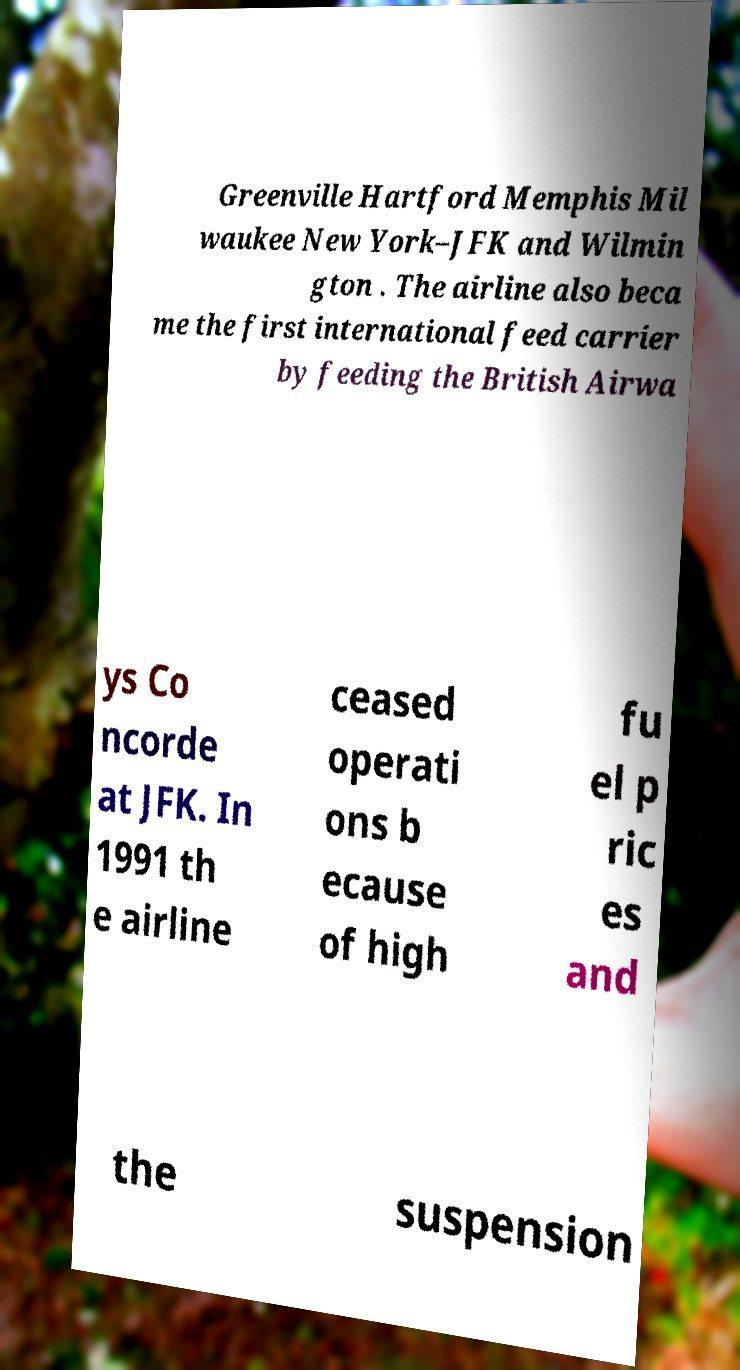Can you read and provide the text displayed in the image?This photo seems to have some interesting text. Can you extract and type it out for me? Greenville Hartford Memphis Mil waukee New York–JFK and Wilmin gton . The airline also beca me the first international feed carrier by feeding the British Airwa ys Co ncorde at JFK. In 1991 th e airline ceased operati ons b ecause of high fu el p ric es and the suspension 